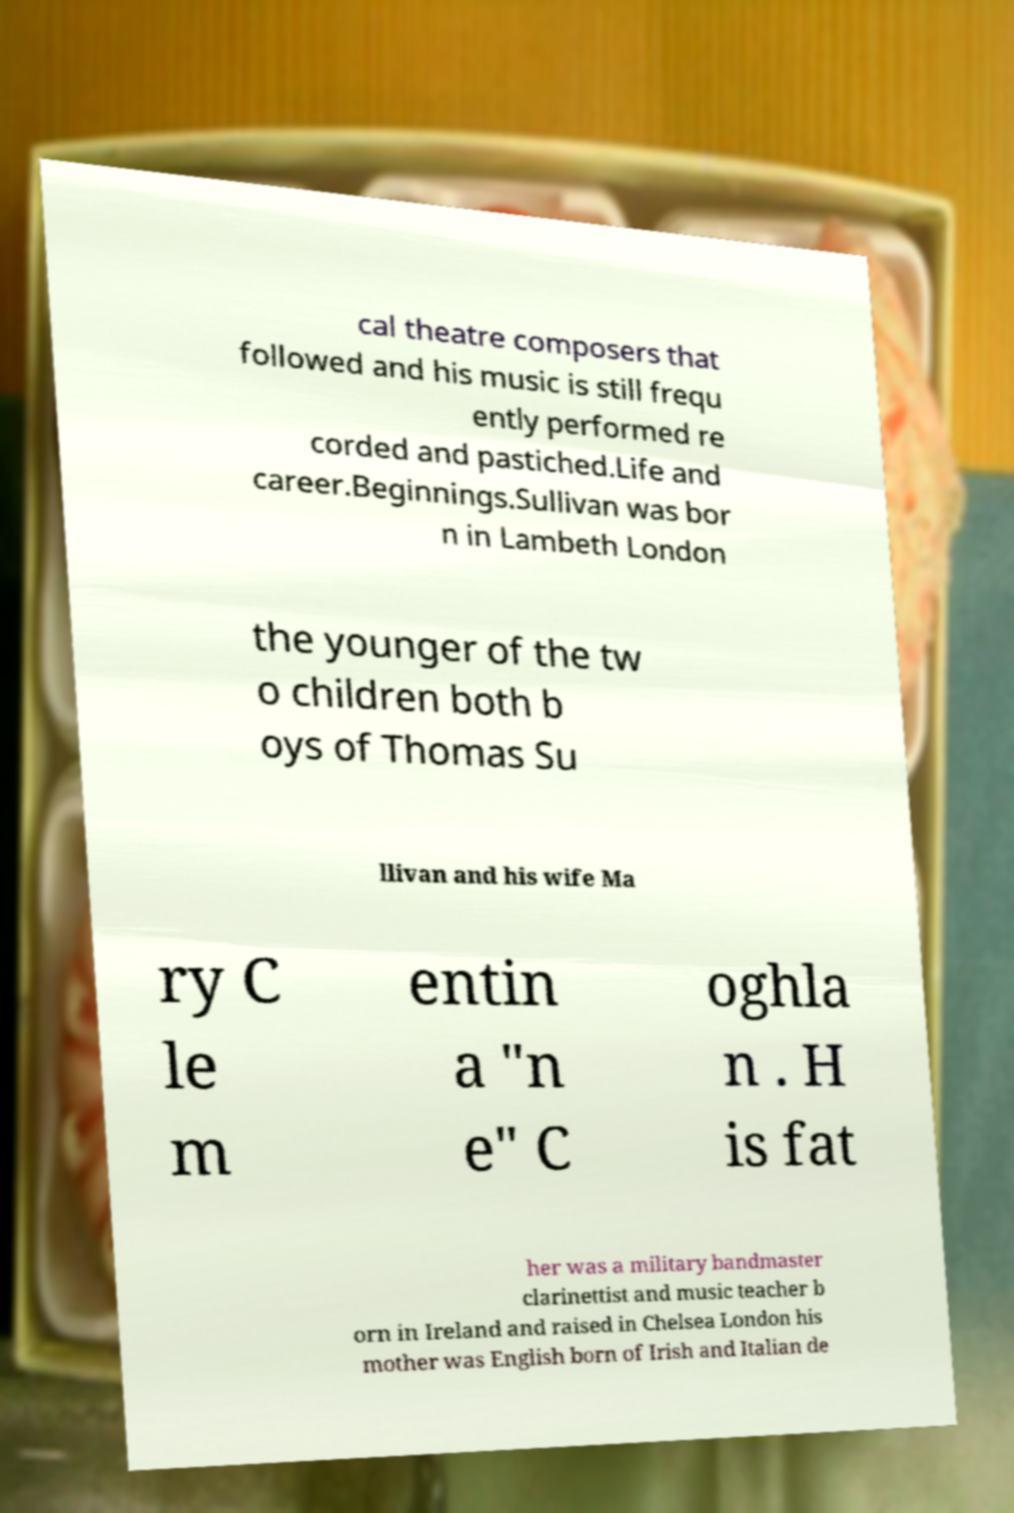Please read and relay the text visible in this image. What does it say? cal theatre composers that followed and his music is still frequ ently performed re corded and pastiched.Life and career.Beginnings.Sullivan was bor n in Lambeth London the younger of the tw o children both b oys of Thomas Su llivan and his wife Ma ry C le m entin a "n e" C oghla n . H is fat her was a military bandmaster clarinettist and music teacher b orn in Ireland and raised in Chelsea London his mother was English born of Irish and Italian de 